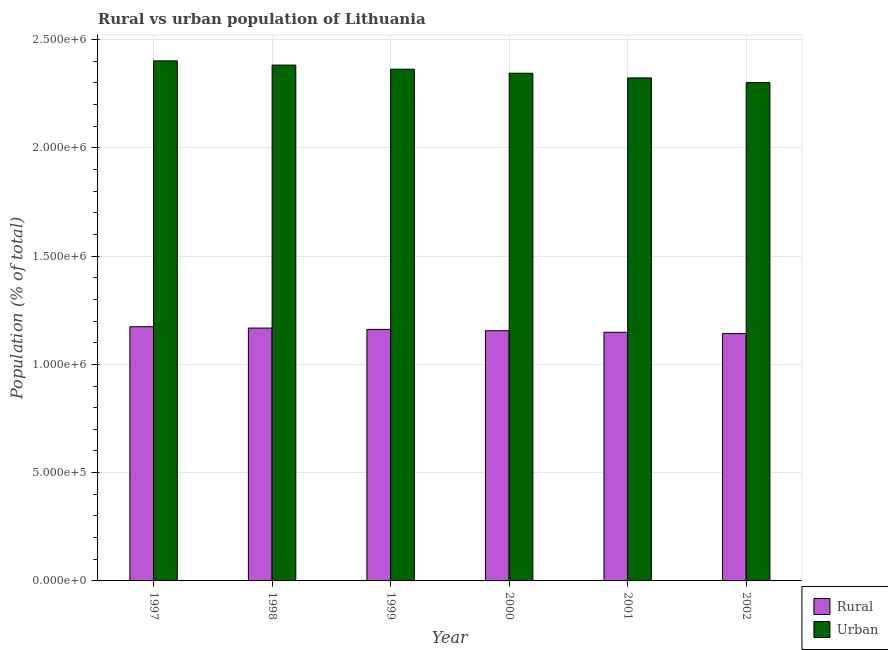How many bars are there on the 6th tick from the left?
Keep it short and to the point. 2. What is the urban population density in 2001?
Offer a very short reply. 2.32e+06. Across all years, what is the maximum rural population density?
Keep it short and to the point. 1.17e+06. Across all years, what is the minimum rural population density?
Provide a short and direct response. 1.14e+06. In which year was the urban population density maximum?
Provide a succinct answer. 1997. In which year was the urban population density minimum?
Make the answer very short. 2002. What is the total urban population density in the graph?
Ensure brevity in your answer.  1.41e+07. What is the difference between the rural population density in 1997 and that in 2002?
Make the answer very short. 3.17e+04. What is the difference between the rural population density in 2000 and the urban population density in 1998?
Give a very brief answer. -1.22e+04. What is the average rural population density per year?
Provide a succinct answer. 1.16e+06. In the year 1997, what is the difference between the urban population density and rural population density?
Give a very brief answer. 0. What is the ratio of the rural population density in 1999 to that in 2000?
Your response must be concise. 1.01. Is the rural population density in 2000 less than that in 2001?
Your answer should be compact. No. What is the difference between the highest and the second highest rural population density?
Provide a succinct answer. 6343. What is the difference between the highest and the lowest urban population density?
Your response must be concise. 1.00e+05. In how many years, is the rural population density greater than the average rural population density taken over all years?
Your response must be concise. 3. What does the 1st bar from the left in 2002 represents?
Keep it short and to the point. Rural. What does the 1st bar from the right in 2000 represents?
Provide a succinct answer. Urban. How many bars are there?
Offer a very short reply. 12. Are all the bars in the graph horizontal?
Ensure brevity in your answer.  No. What is the difference between two consecutive major ticks on the Y-axis?
Your answer should be compact. 5.00e+05. Are the values on the major ticks of Y-axis written in scientific E-notation?
Your answer should be compact. Yes. What is the title of the graph?
Make the answer very short. Rural vs urban population of Lithuania. Does "Taxes on exports" appear as one of the legend labels in the graph?
Offer a terse response. No. What is the label or title of the Y-axis?
Give a very brief answer. Population (% of total). What is the Population (% of total) of Rural in 1997?
Provide a succinct answer. 1.17e+06. What is the Population (% of total) of Urban in 1997?
Make the answer very short. 2.40e+06. What is the Population (% of total) in Rural in 1998?
Your answer should be compact. 1.17e+06. What is the Population (% of total) in Urban in 1998?
Give a very brief answer. 2.38e+06. What is the Population (% of total) of Rural in 1999?
Provide a succinct answer. 1.16e+06. What is the Population (% of total) in Urban in 1999?
Your answer should be very brief. 2.36e+06. What is the Population (% of total) of Rural in 2000?
Give a very brief answer. 1.16e+06. What is the Population (% of total) in Urban in 2000?
Provide a short and direct response. 2.34e+06. What is the Population (% of total) of Rural in 2001?
Your response must be concise. 1.15e+06. What is the Population (% of total) in Urban in 2001?
Provide a short and direct response. 2.32e+06. What is the Population (% of total) in Rural in 2002?
Offer a very short reply. 1.14e+06. What is the Population (% of total) of Urban in 2002?
Your answer should be compact. 2.30e+06. Across all years, what is the maximum Population (% of total) of Rural?
Your answer should be very brief. 1.17e+06. Across all years, what is the maximum Population (% of total) of Urban?
Your response must be concise. 2.40e+06. Across all years, what is the minimum Population (% of total) of Rural?
Your answer should be compact. 1.14e+06. Across all years, what is the minimum Population (% of total) of Urban?
Your answer should be very brief. 2.30e+06. What is the total Population (% of total) of Rural in the graph?
Provide a short and direct response. 6.95e+06. What is the total Population (% of total) of Urban in the graph?
Ensure brevity in your answer.  1.41e+07. What is the difference between the Population (% of total) in Rural in 1997 and that in 1998?
Provide a short and direct response. 6343. What is the difference between the Population (% of total) in Urban in 1997 and that in 1998?
Keep it short and to the point. 1.95e+04. What is the difference between the Population (% of total) in Rural in 1997 and that in 1999?
Give a very brief answer. 1.25e+04. What is the difference between the Population (% of total) in Urban in 1997 and that in 1999?
Your answer should be very brief. 3.84e+04. What is the difference between the Population (% of total) of Rural in 1997 and that in 2000?
Provide a short and direct response. 1.85e+04. What is the difference between the Population (% of total) of Urban in 1997 and that in 2000?
Offer a very short reply. 5.71e+04. What is the difference between the Population (% of total) of Rural in 1997 and that in 2001?
Your answer should be very brief. 2.57e+04. What is the difference between the Population (% of total) of Urban in 1997 and that in 2001?
Provide a short and direct response. 7.86e+04. What is the difference between the Population (% of total) of Rural in 1997 and that in 2002?
Ensure brevity in your answer.  3.17e+04. What is the difference between the Population (% of total) in Urban in 1997 and that in 2002?
Ensure brevity in your answer.  1.00e+05. What is the difference between the Population (% of total) in Rural in 1998 and that in 1999?
Your answer should be very brief. 6140. What is the difference between the Population (% of total) of Urban in 1998 and that in 1999?
Your response must be concise. 1.90e+04. What is the difference between the Population (% of total) in Rural in 1998 and that in 2000?
Your answer should be compact. 1.22e+04. What is the difference between the Population (% of total) in Urban in 1998 and that in 2000?
Your answer should be compact. 3.76e+04. What is the difference between the Population (% of total) of Rural in 1998 and that in 2001?
Offer a very short reply. 1.93e+04. What is the difference between the Population (% of total) of Urban in 1998 and that in 2001?
Keep it short and to the point. 5.92e+04. What is the difference between the Population (% of total) in Rural in 1998 and that in 2002?
Your answer should be very brief. 2.54e+04. What is the difference between the Population (% of total) in Urban in 1998 and that in 2002?
Give a very brief answer. 8.09e+04. What is the difference between the Population (% of total) of Rural in 1999 and that in 2000?
Your answer should be compact. 6040. What is the difference between the Population (% of total) of Urban in 1999 and that in 2000?
Make the answer very short. 1.87e+04. What is the difference between the Population (% of total) in Rural in 1999 and that in 2001?
Offer a terse response. 1.32e+04. What is the difference between the Population (% of total) of Urban in 1999 and that in 2001?
Offer a terse response. 4.02e+04. What is the difference between the Population (% of total) in Rural in 1999 and that in 2002?
Your answer should be compact. 1.92e+04. What is the difference between the Population (% of total) of Urban in 1999 and that in 2002?
Offer a very short reply. 6.19e+04. What is the difference between the Population (% of total) of Rural in 2000 and that in 2001?
Offer a very short reply. 7156. What is the difference between the Population (% of total) of Urban in 2000 and that in 2001?
Offer a terse response. 2.16e+04. What is the difference between the Population (% of total) in Rural in 2000 and that in 2002?
Ensure brevity in your answer.  1.32e+04. What is the difference between the Population (% of total) of Urban in 2000 and that in 2002?
Give a very brief answer. 4.33e+04. What is the difference between the Population (% of total) of Rural in 2001 and that in 2002?
Offer a terse response. 6047. What is the difference between the Population (% of total) in Urban in 2001 and that in 2002?
Provide a succinct answer. 2.17e+04. What is the difference between the Population (% of total) of Rural in 1997 and the Population (% of total) of Urban in 1998?
Keep it short and to the point. -1.21e+06. What is the difference between the Population (% of total) in Rural in 1997 and the Population (% of total) in Urban in 1999?
Make the answer very short. -1.19e+06. What is the difference between the Population (% of total) of Rural in 1997 and the Population (% of total) of Urban in 2000?
Provide a succinct answer. -1.17e+06. What is the difference between the Population (% of total) of Rural in 1997 and the Population (% of total) of Urban in 2001?
Offer a very short reply. -1.15e+06. What is the difference between the Population (% of total) in Rural in 1997 and the Population (% of total) in Urban in 2002?
Ensure brevity in your answer.  -1.13e+06. What is the difference between the Population (% of total) in Rural in 1998 and the Population (% of total) in Urban in 1999?
Make the answer very short. -1.20e+06. What is the difference between the Population (% of total) in Rural in 1998 and the Population (% of total) in Urban in 2000?
Your answer should be very brief. -1.18e+06. What is the difference between the Population (% of total) in Rural in 1998 and the Population (% of total) in Urban in 2001?
Offer a terse response. -1.16e+06. What is the difference between the Population (% of total) in Rural in 1998 and the Population (% of total) in Urban in 2002?
Offer a very short reply. -1.13e+06. What is the difference between the Population (% of total) of Rural in 1999 and the Population (% of total) of Urban in 2000?
Offer a very short reply. -1.18e+06. What is the difference between the Population (% of total) in Rural in 1999 and the Population (% of total) in Urban in 2001?
Offer a terse response. -1.16e+06. What is the difference between the Population (% of total) of Rural in 1999 and the Population (% of total) of Urban in 2002?
Provide a succinct answer. -1.14e+06. What is the difference between the Population (% of total) of Rural in 2000 and the Population (% of total) of Urban in 2001?
Keep it short and to the point. -1.17e+06. What is the difference between the Population (% of total) in Rural in 2000 and the Population (% of total) in Urban in 2002?
Keep it short and to the point. -1.15e+06. What is the difference between the Population (% of total) in Rural in 2001 and the Population (% of total) in Urban in 2002?
Offer a very short reply. -1.15e+06. What is the average Population (% of total) in Rural per year?
Offer a terse response. 1.16e+06. What is the average Population (% of total) in Urban per year?
Ensure brevity in your answer.  2.35e+06. In the year 1997, what is the difference between the Population (% of total) in Rural and Population (% of total) in Urban?
Give a very brief answer. -1.23e+06. In the year 1998, what is the difference between the Population (% of total) of Rural and Population (% of total) of Urban?
Your response must be concise. -1.21e+06. In the year 1999, what is the difference between the Population (% of total) in Rural and Population (% of total) in Urban?
Make the answer very short. -1.20e+06. In the year 2000, what is the difference between the Population (% of total) of Rural and Population (% of total) of Urban?
Provide a short and direct response. -1.19e+06. In the year 2001, what is the difference between the Population (% of total) in Rural and Population (% of total) in Urban?
Provide a short and direct response. -1.17e+06. In the year 2002, what is the difference between the Population (% of total) in Rural and Population (% of total) in Urban?
Provide a short and direct response. -1.16e+06. What is the ratio of the Population (% of total) of Rural in 1997 to that in 1998?
Give a very brief answer. 1.01. What is the ratio of the Population (% of total) in Urban in 1997 to that in 1998?
Make the answer very short. 1.01. What is the ratio of the Population (% of total) in Rural in 1997 to that in 1999?
Your response must be concise. 1.01. What is the ratio of the Population (% of total) of Urban in 1997 to that in 1999?
Offer a very short reply. 1.02. What is the ratio of the Population (% of total) of Urban in 1997 to that in 2000?
Provide a short and direct response. 1.02. What is the ratio of the Population (% of total) of Rural in 1997 to that in 2001?
Provide a succinct answer. 1.02. What is the ratio of the Population (% of total) of Urban in 1997 to that in 2001?
Keep it short and to the point. 1.03. What is the ratio of the Population (% of total) of Rural in 1997 to that in 2002?
Your answer should be compact. 1.03. What is the ratio of the Population (% of total) of Urban in 1997 to that in 2002?
Give a very brief answer. 1.04. What is the ratio of the Population (% of total) of Rural in 1998 to that in 1999?
Ensure brevity in your answer.  1.01. What is the ratio of the Population (% of total) of Urban in 1998 to that in 1999?
Your response must be concise. 1.01. What is the ratio of the Population (% of total) of Rural in 1998 to that in 2000?
Make the answer very short. 1.01. What is the ratio of the Population (% of total) of Urban in 1998 to that in 2000?
Your answer should be compact. 1.02. What is the ratio of the Population (% of total) of Rural in 1998 to that in 2001?
Keep it short and to the point. 1.02. What is the ratio of the Population (% of total) in Urban in 1998 to that in 2001?
Your answer should be compact. 1.03. What is the ratio of the Population (% of total) of Rural in 1998 to that in 2002?
Your answer should be compact. 1.02. What is the ratio of the Population (% of total) of Urban in 1998 to that in 2002?
Make the answer very short. 1.04. What is the ratio of the Population (% of total) of Rural in 1999 to that in 2000?
Give a very brief answer. 1.01. What is the ratio of the Population (% of total) in Urban in 1999 to that in 2000?
Ensure brevity in your answer.  1.01. What is the ratio of the Population (% of total) in Rural in 1999 to that in 2001?
Offer a very short reply. 1.01. What is the ratio of the Population (% of total) in Urban in 1999 to that in 2001?
Ensure brevity in your answer.  1.02. What is the ratio of the Population (% of total) of Rural in 1999 to that in 2002?
Make the answer very short. 1.02. What is the ratio of the Population (% of total) in Urban in 1999 to that in 2002?
Ensure brevity in your answer.  1.03. What is the ratio of the Population (% of total) in Urban in 2000 to that in 2001?
Your answer should be very brief. 1.01. What is the ratio of the Population (% of total) of Rural in 2000 to that in 2002?
Make the answer very short. 1.01. What is the ratio of the Population (% of total) in Urban in 2000 to that in 2002?
Keep it short and to the point. 1.02. What is the ratio of the Population (% of total) in Urban in 2001 to that in 2002?
Offer a terse response. 1.01. What is the difference between the highest and the second highest Population (% of total) in Rural?
Provide a short and direct response. 6343. What is the difference between the highest and the second highest Population (% of total) in Urban?
Your answer should be very brief. 1.95e+04. What is the difference between the highest and the lowest Population (% of total) in Rural?
Offer a terse response. 3.17e+04. What is the difference between the highest and the lowest Population (% of total) of Urban?
Provide a succinct answer. 1.00e+05. 